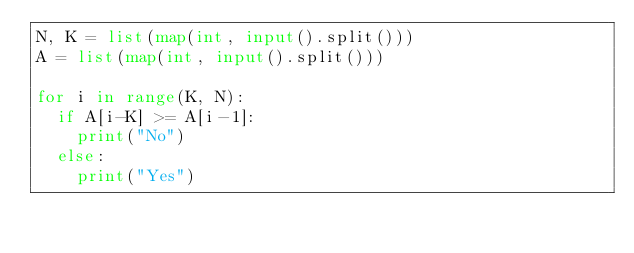<code> <loc_0><loc_0><loc_500><loc_500><_Python_>N, K = list(map(int, input().split()))
A = list(map(int, input().split()))

for i in range(K, N):
  if A[i-K] >= A[i-1]:
    print("No")
  else:
    print("Yes")
</code> 